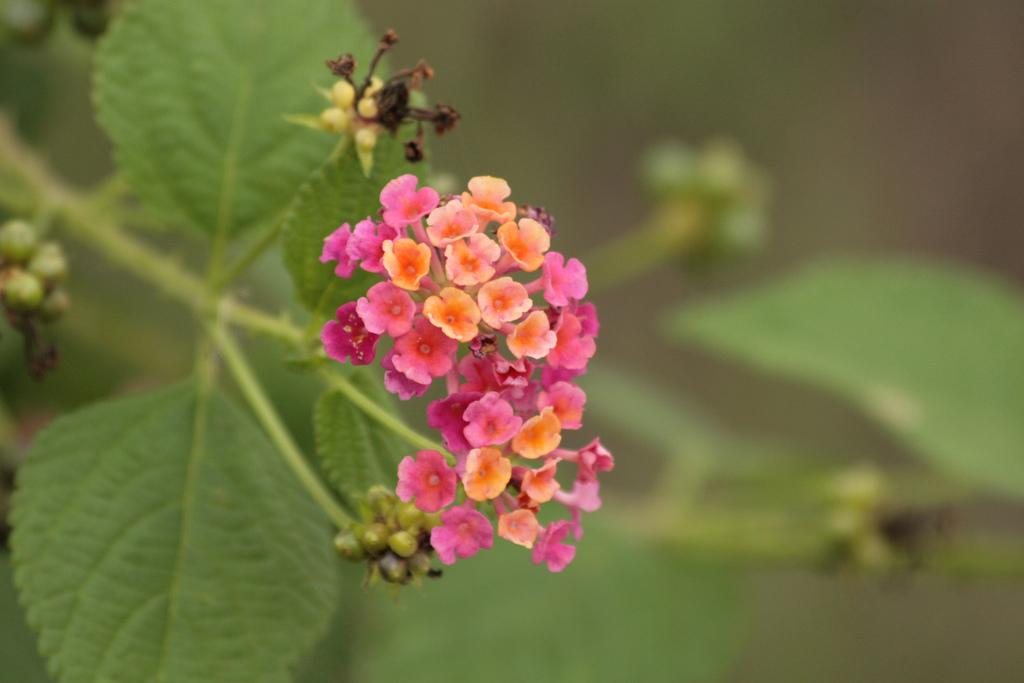What is present in the image? There is a plant in the image. Can you describe the plant in more detail? The plant has flowers and buds. What colors are the flowers? The flowers are in pink and orange colors. How would you describe the background of the image? The background of the image is blurry. What type of stone can be seen in the image? There is no stone present in the image; it features a plant with flowers and buds. What industry is depicted in the image? There is no industry depicted in the image; it features a plant with flowers and buds. 